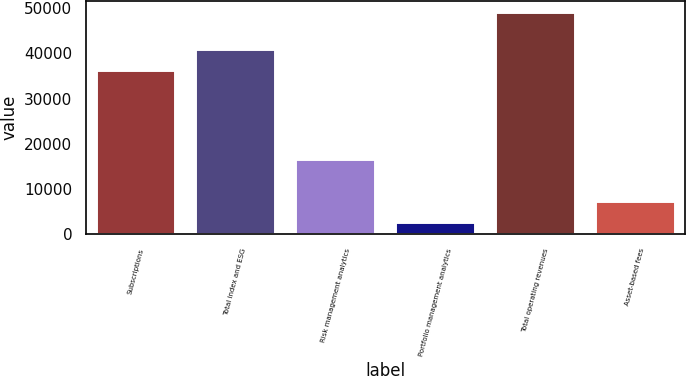Convert chart to OTSL. <chart><loc_0><loc_0><loc_500><loc_500><bar_chart><fcel>Subscriptions<fcel>Total index and ESG<fcel>Risk management analytics<fcel>Portfolio management analytics<fcel>Total operating revenues<fcel>Asset-based fees<nl><fcel>36240<fcel>40884.4<fcel>16706<fcel>2756<fcel>49200<fcel>7400.4<nl></chart> 